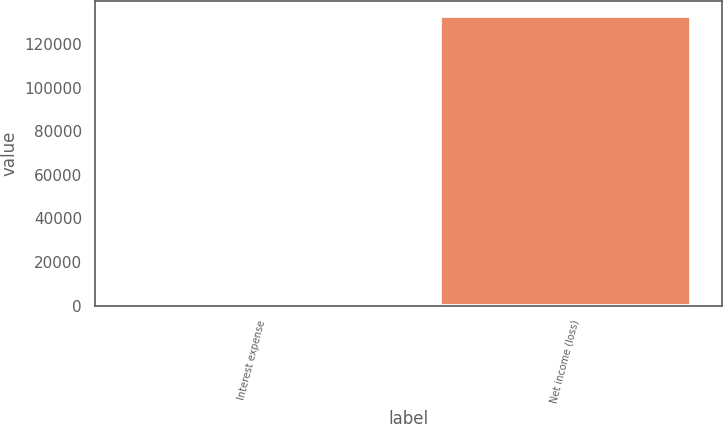Convert chart to OTSL. <chart><loc_0><loc_0><loc_500><loc_500><bar_chart><fcel>Interest expense<fcel>Net income (loss)<nl><fcel>506<fcel>133056<nl></chart> 